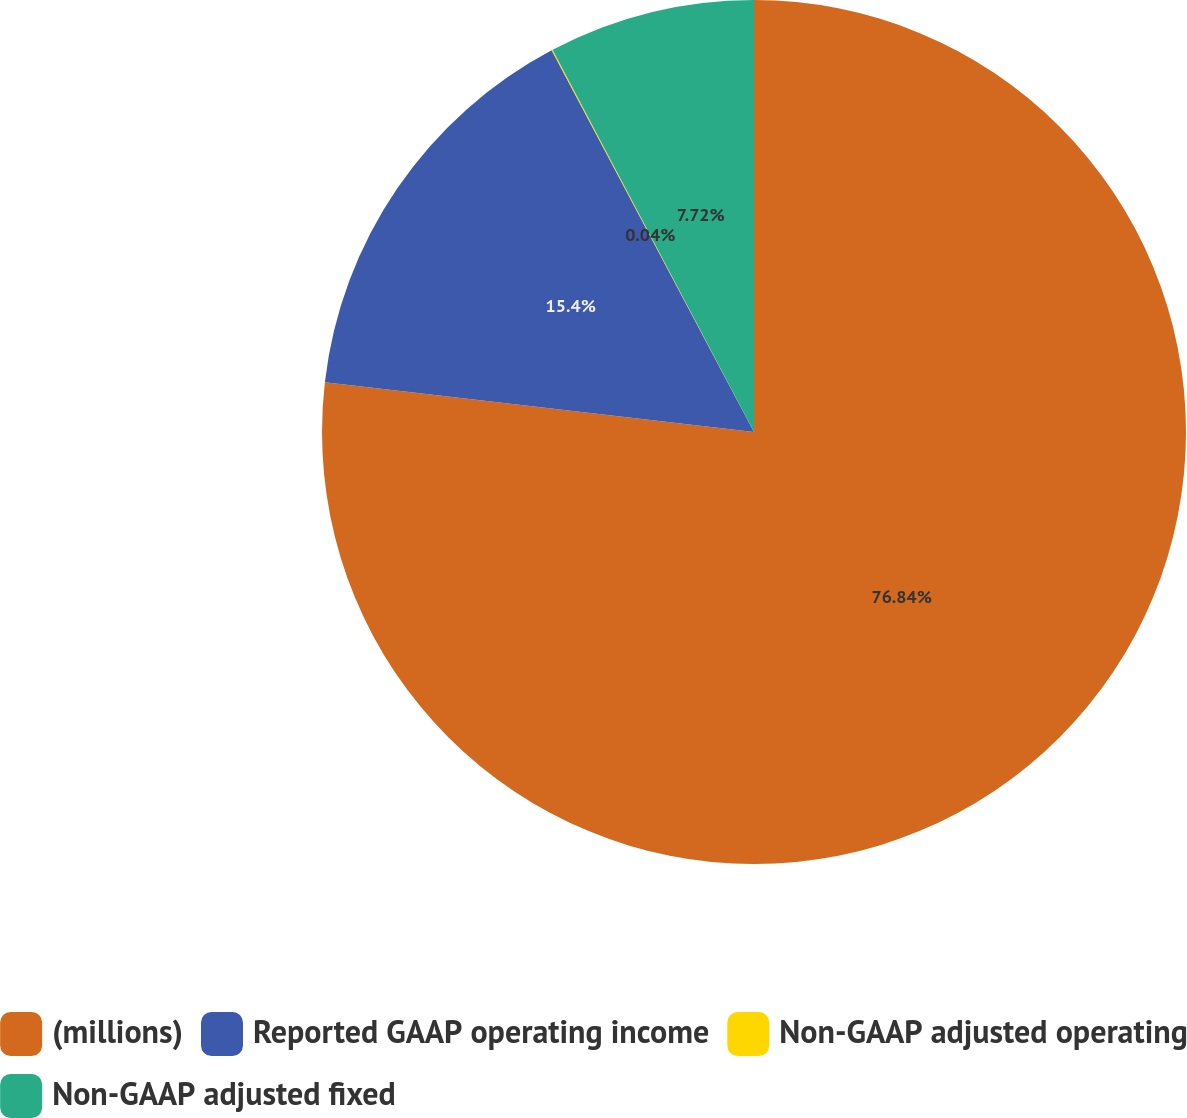<chart> <loc_0><loc_0><loc_500><loc_500><pie_chart><fcel>(millions)<fcel>Reported GAAP operating income<fcel>Non-GAAP adjusted operating<fcel>Non-GAAP adjusted fixed<nl><fcel>76.84%<fcel>15.4%<fcel>0.04%<fcel>7.72%<nl></chart> 